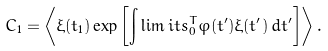Convert formula to latex. <formula><loc_0><loc_0><loc_500><loc_500>C _ { 1 } = \left \langle \xi ( t _ { 1 } ) \exp \left [ \int \lim i t s _ { 0 } ^ { T } \varphi ( t ^ { \prime } ) \xi ( t ^ { \prime } ) \, d t ^ { \prime } \right ] \right \rangle .</formula> 